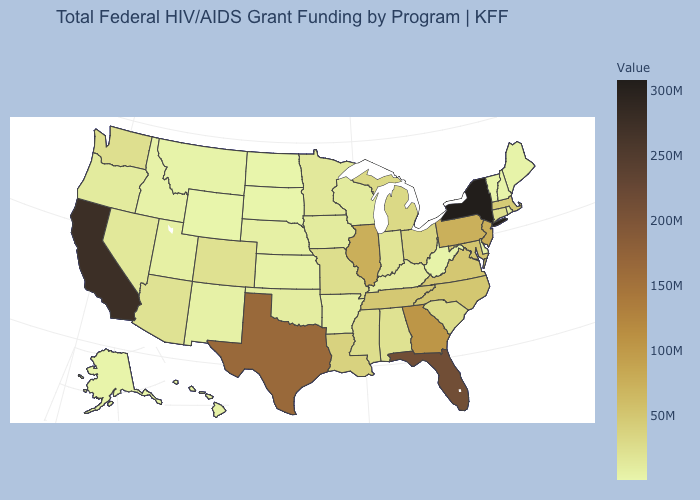Does Alaska have the highest value in the USA?
Be succinct. No. Does the map have missing data?
Give a very brief answer. No. Which states hav the highest value in the Northeast?
Give a very brief answer. New York. Among the states that border Mississippi , does Alabama have the highest value?
Be succinct. No. 